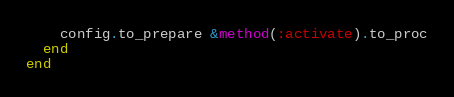Convert code to text. <code><loc_0><loc_0><loc_500><loc_500><_Ruby_>    config.to_prepare &method(:activate).to_proc
  end
end
</code> 